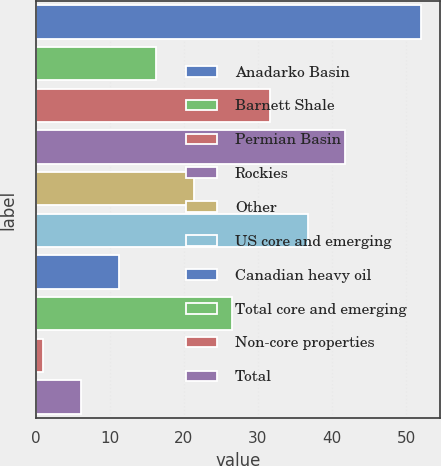<chart> <loc_0><loc_0><loc_500><loc_500><bar_chart><fcel>Anadarko Basin<fcel>Barnett Shale<fcel>Permian Basin<fcel>Rockies<fcel>Other<fcel>US core and emerging<fcel>Canadian heavy oil<fcel>Total core and emerging<fcel>Non-core properties<fcel>Total<nl><fcel>52<fcel>16.3<fcel>31.6<fcel>41.8<fcel>21.4<fcel>36.7<fcel>11.2<fcel>26.5<fcel>1<fcel>6.1<nl></chart> 